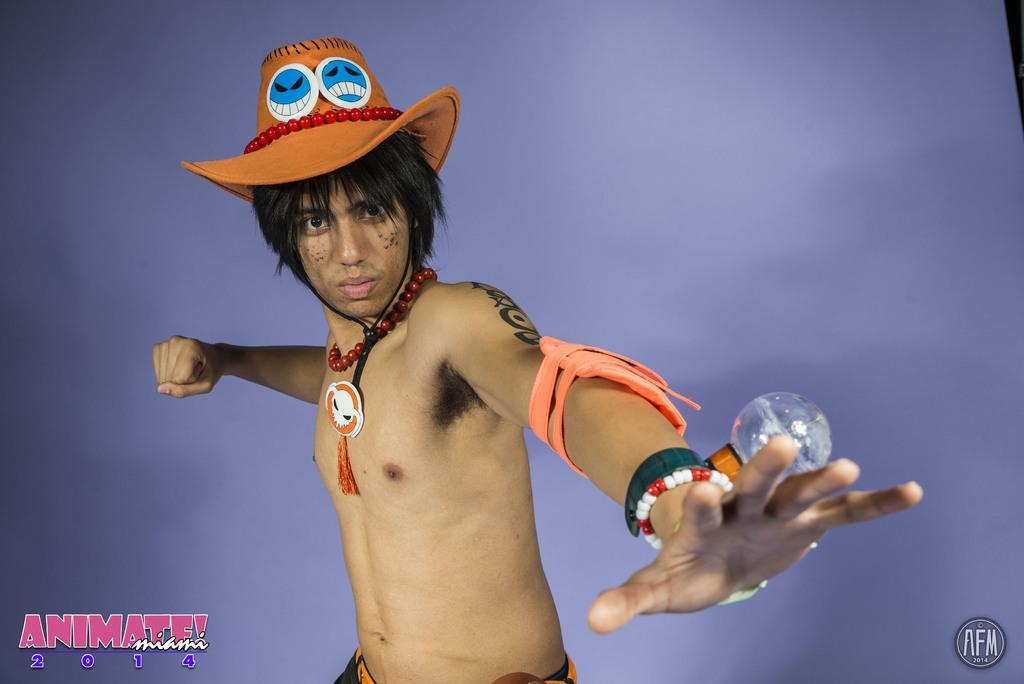What is the main subject of the image? There is a person in the image. Can you describe the person's attire? The person is wearing a cap. What is visible behind the person? There is a wall behind the person. What additional information can be found at the bottom of the image? There are watermarks, text, and numbers at the bottom of the image. What type of branch is the person holding in the image? There is no branch present in the image. What kind of structure is the person standing next to in the image? The image only shows a person and a wall, so there is no other structure present. Is the person holding a gun in the image? There is no gun visible in the image. 